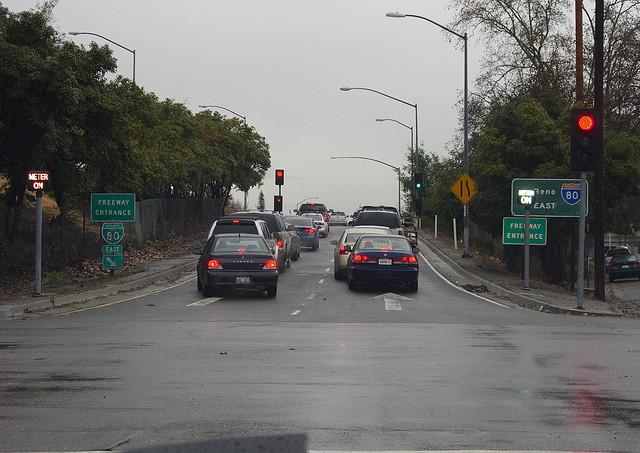What does the green sign say?
Concise answer only. Freeway entrance. Was it taken at night?
Give a very brief answer. No. Are these cars heading to one direction?
Short answer required. Yes. What mode of transportation is this?
Concise answer only. Car. Is this a busy street?
Quick response, please. Yes. How many red lights are there?
Keep it brief. 3. Is this a traffic jam?
Short answer required. Yes. What color is the traffic light?
Give a very brief answer. Red. Is the sun bright?
Keep it brief. No. 